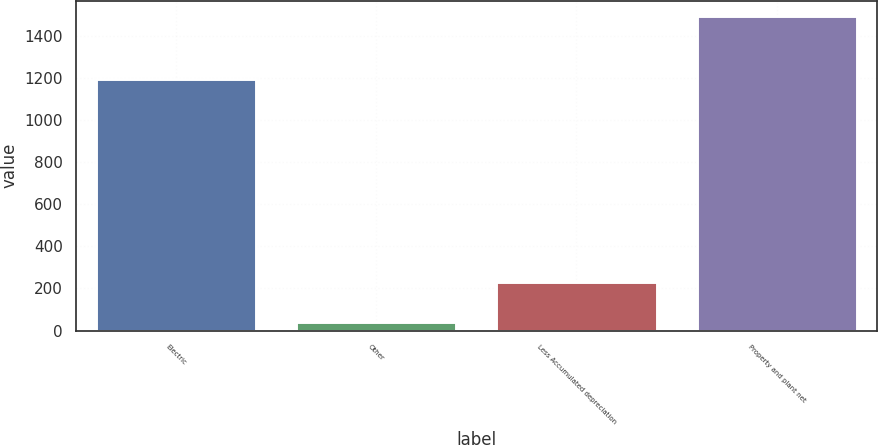Convert chart. <chart><loc_0><loc_0><loc_500><loc_500><bar_chart><fcel>Electric<fcel>Other<fcel>Less Accumulated depreciation<fcel>Property and plant net<nl><fcel>1196<fcel>42<fcel>231<fcel>1494<nl></chart> 